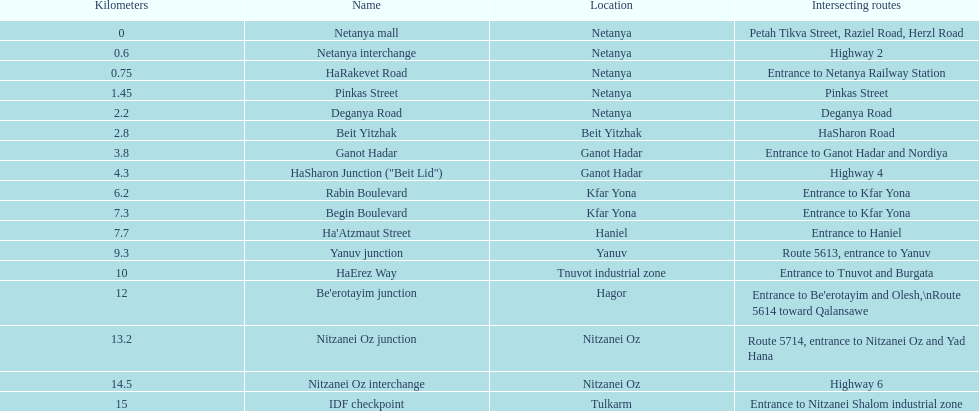After you complete deganya road, what portion comes next? Beit Yitzhak. 